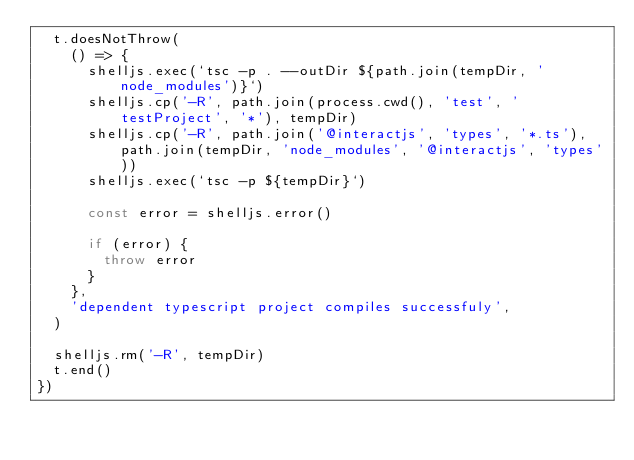Convert code to text. <code><loc_0><loc_0><loc_500><loc_500><_TypeScript_>  t.doesNotThrow(
    () => {
      shelljs.exec(`tsc -p . --outDir ${path.join(tempDir, 'node_modules')}`)
      shelljs.cp('-R', path.join(process.cwd(), 'test', 'testProject', '*'), tempDir)
      shelljs.cp('-R', path.join('@interactjs', 'types', '*.ts'), path.join(tempDir, 'node_modules', '@interactjs', 'types'))
      shelljs.exec(`tsc -p ${tempDir}`)

      const error = shelljs.error()

      if (error) {
        throw error
      }
    },
    'dependent typescript project compiles successfuly',
  )

  shelljs.rm('-R', tempDir)
  t.end()
})
</code> 